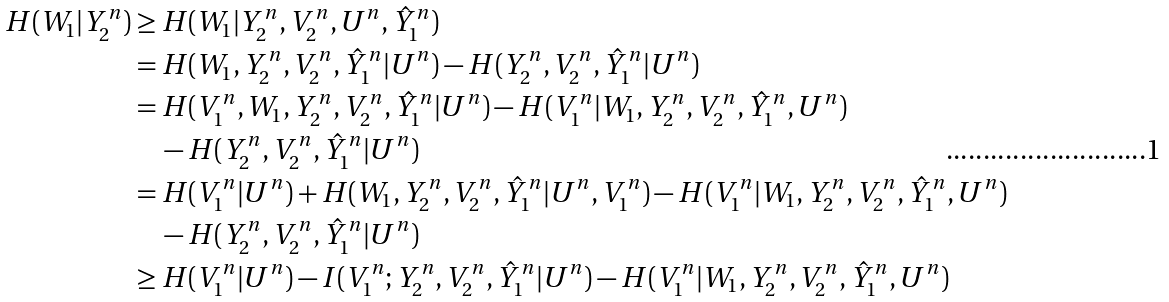<formula> <loc_0><loc_0><loc_500><loc_500>H ( W _ { 1 } | Y _ { 2 } ^ { n } ) & \geq H ( W _ { 1 } | Y _ { 2 } ^ { n } , V _ { 2 } ^ { n } , U ^ { n } , \hat { Y } _ { 1 } ^ { n } ) \\ & = H ( W _ { 1 } , Y _ { 2 } ^ { n } , V _ { 2 } ^ { n } , \hat { Y } _ { 1 } ^ { n } | U ^ { n } ) - H ( Y _ { 2 } ^ { n } , V _ { 2 } ^ { n } , \hat { Y } _ { 1 } ^ { n } | U ^ { n } ) \\ & = H ( V _ { 1 } ^ { n } , W _ { 1 } , Y _ { 2 } ^ { n } , V _ { 2 } ^ { n } , \hat { Y } _ { 1 } ^ { n } | U ^ { n } ) - H ( V _ { 1 } ^ { n } | W _ { 1 } , Y _ { 2 } ^ { n } , V _ { 2 } ^ { n } , \hat { Y } _ { 1 } ^ { n } , U ^ { n } ) \\ & \quad - H ( Y _ { 2 } ^ { n } , V _ { 2 } ^ { n } , \hat { Y } _ { 1 } ^ { n } | U ^ { n } ) \\ & = H ( V _ { 1 } ^ { n } | U ^ { n } ) + H ( W _ { 1 } , Y _ { 2 } ^ { n } , V _ { 2 } ^ { n } , \hat { Y } _ { 1 } ^ { n } | U ^ { n } , V _ { 1 } ^ { n } ) - H ( V _ { 1 } ^ { n } | W _ { 1 } , Y _ { 2 } ^ { n } , V _ { 2 } ^ { n } , \hat { Y } _ { 1 } ^ { n } , U ^ { n } ) \\ & \quad - H ( Y _ { 2 } ^ { n } , V _ { 2 } ^ { n } , \hat { Y } _ { 1 } ^ { n } | U ^ { n } ) \\ & \geq H ( V _ { 1 } ^ { n } | U ^ { n } ) - I ( V _ { 1 } ^ { n } ; Y _ { 2 } ^ { n } , V _ { 2 } ^ { n } , \hat { Y } _ { 1 } ^ { n } | U ^ { n } ) - H ( V _ { 1 } ^ { n } | W _ { 1 } , Y _ { 2 } ^ { n } , V _ { 2 } ^ { n } , \hat { Y } _ { 1 } ^ { n } , U ^ { n } )</formula> 